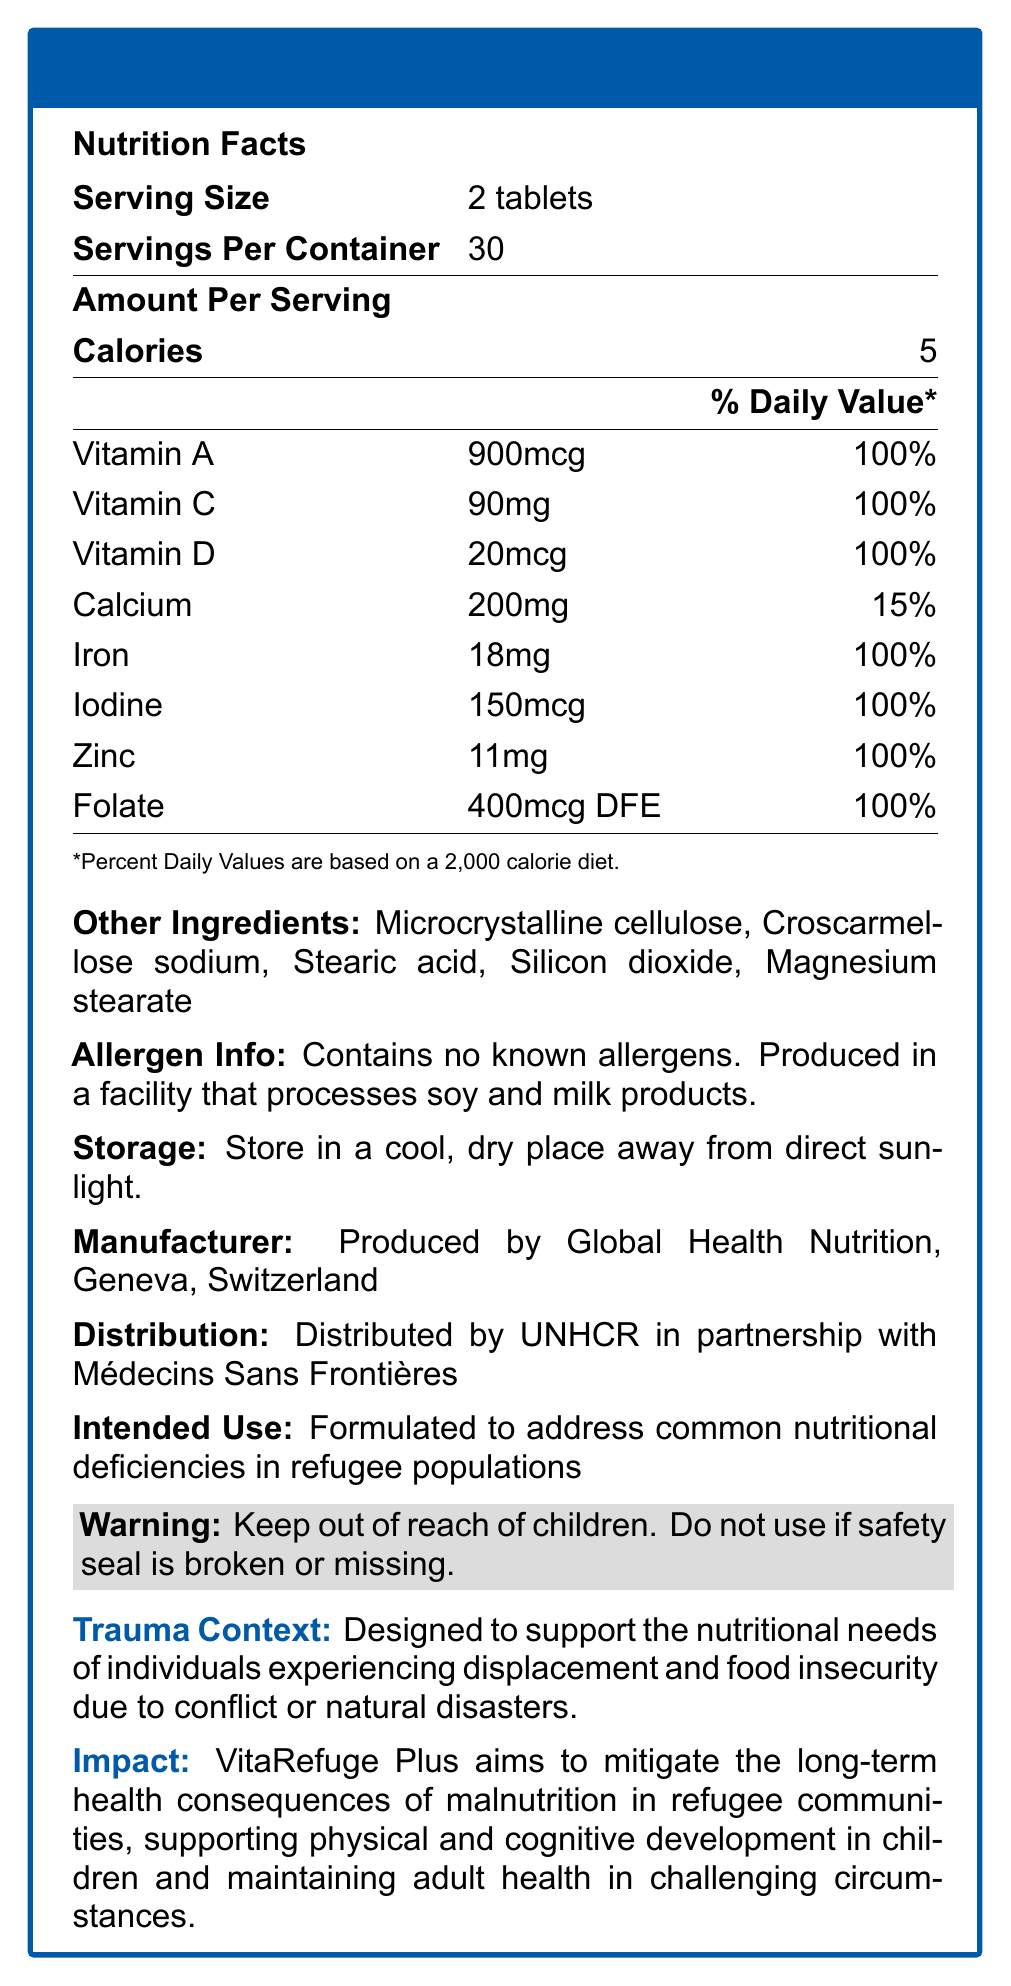what is the serving size of VitaRefuge Plus? The document states that the serving size is 2 tablets.
Answer: 2 tablets how many calories are there per serving? The document mentions that there are 5 calories per serving.
Answer: 5 who manufactures VitaRefuge Plus? The document lists the manufacturer as Global Health Nutrition, Geneva, Switzerland.
Answer: Global Health Nutrition, Geneva, Switzerland who distributes VitaRefuge Plus? The document states that the product is distributed by UNHCR in partnership with Médecins Sans Frontières.
Answer: UNHCR in partnership with Médecins Sans Frontières what is the daily value percentage of vitamin D? According to the document, the daily value percentage for vitamin D is 100%.
Answer: 100% which nutrient has the highest quantity in micrograms (mcg) per serving? A. Vitamin A B. Vitamin D C. Iodine The document lists Vitamin A with 900mcg, which is higher than Vitamin D (20mcg) and Iodine (150mcg).
Answer: A. Vitamin A what should you do if the safety seal is broken or missing? A. Use with caution B. Do not use C. Store in a cool place The warning statement in the document advises not to use the product if the safety seal is broken or missing.
Answer: B. Do not use what is the allergen information provided? The document states that it contains no known allergens and is produced in a facility that processes soy and milk products.
Answer: Contains no known allergens. Produced in a facility that processes soy and milk products. is there iron in VitaRefuge Plus? The document lists iron as one of the nutrients, with an amount of 18mg and 100% daily value.
Answer: Yes what is the intended use of VitaRefuge Plus? The document specifies that the intended use is to address common nutritional deficiencies in refugee populations.
Answer: Formulated to address common nutritional deficiencies in refugee populations describe the main idea of the document. The document outlines the nutrition facts for VitaRefuge Plus, its purpose in addressing nutritional deficiencies in refugee populations, and other relevant details such as storage instructions, allergen information, and the impact of the supplement on refugee health.
Answer: The document provides detailed nutritional information for VitaRefuge Plus, a vitamin supplement designed for refugees and displaced persons. It includes nutritional content, serving size, manufacturer and distribution details, intended use, and warnings. how does VitaRefuge Plus aim to support refugee communities? The impact statement mentions that the supplement aims to mitigate malnutrition's long-term health consequences, support physical and cognitive development in children, and maintain adult health in challenging circumstances.
Answer: Mitigate the long-term health consequences of malnutrition, supporting physical and cognitive development in children and maintaining adult health what is the storage instruction for VitaRefuge Plus? The document clearly states the storage instruction as storing it in a cool, dry place away from direct sunlight.
Answer: Store in a cool, dry place away from direct sunlight. how many servings are there in one container of VitaRefuge Plus? The document specifies that there are 30 servings per container.
Answer: 30 does the product contain allergens? The allergen info states that it contains no known allergens, although it is produced in a facility that processes soy and milk products.
Answer: No what are some of the other ingredients in the supplement? The document lists these as other ingredients in the supplement.
Answer: Microcrystalline cellulose, Croscarmellose sodium, Stearic acid, Silicon dioxide, Magnesium stearate what is the color of the border used in the visual document? The document's styling indicates the use of the color "Refugee Blue" for the border.
Answer: Refugee Blue which organization is not mentioned in the distribution info? A. UNHCR B. World Health Organization C. Médecins Sans Frontières The distribution information mentions UNHCR and Médecins Sans Frontières, but not the World Health Organization.
Answer: B. World Health Organization what specific needs does the supplement address? The trauma context states that it is designed to support individuals experiencing displacement and food insecurity due to conflict or natural disasters.
Answer: The nutritional needs of individuals experiencing displacement and food insecurity due to conflict or natural disasters. what percentage of the daily value does one serving of iron provide? According to the nutrition facts, one serving of iron provides 100% of the daily value.
Answer: 100% what is the impact statement of VitaRefuge Plus? The document includes an impact statement detailing the objectives of VitaRefuge Plus.
Answer: VitaRefuge Plus aims to mitigate the long-term health consequences of malnutrition in refugee communities, supporting physical and cognitive development in children and maintaining adult health in challenging circumstances. what is the difference between the amount of calcium and zinc per serving? The document states 200mg of calcium and 11mg of zinc per serving; the difference is 200mg - 11mg = 189 mg.
Answer: 189 mg how effective is the supplement at fulfilling daily vitamin C needs? The document indicates that one serving of the supplement provides 100% of the daily value for Vitamin C.
Answer: 100% who distributed the documents of VitaRefuge Plus? The document does not specify who created or distributed the visual document itself.
Answer: Cannot be determined 